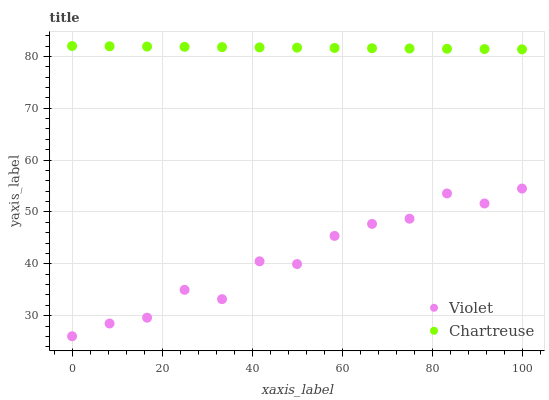Does Violet have the minimum area under the curve?
Answer yes or no. Yes. Does Chartreuse have the maximum area under the curve?
Answer yes or no. Yes. Does Violet have the maximum area under the curve?
Answer yes or no. No. Is Chartreuse the smoothest?
Answer yes or no. Yes. Is Violet the roughest?
Answer yes or no. Yes. Is Violet the smoothest?
Answer yes or no. No. Does Violet have the lowest value?
Answer yes or no. Yes. Does Chartreuse have the highest value?
Answer yes or no. Yes. Does Violet have the highest value?
Answer yes or no. No. Is Violet less than Chartreuse?
Answer yes or no. Yes. Is Chartreuse greater than Violet?
Answer yes or no. Yes. Does Violet intersect Chartreuse?
Answer yes or no. No. 